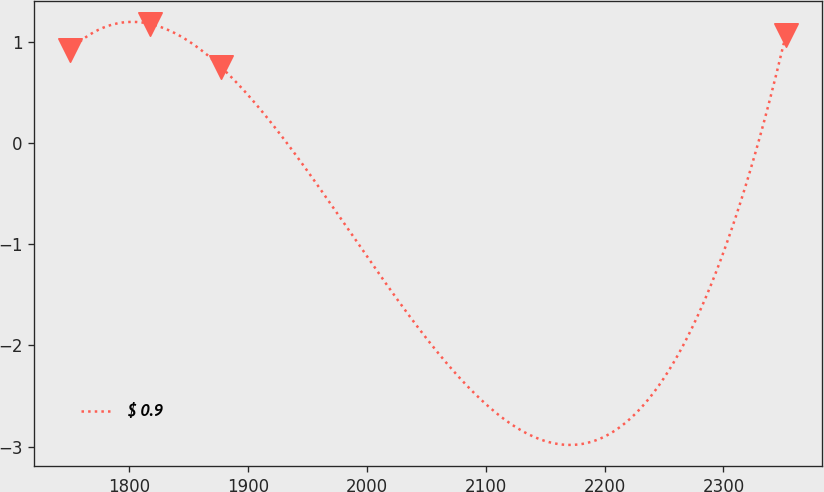<chart> <loc_0><loc_0><loc_500><loc_500><line_chart><ecel><fcel>$ 0.9<nl><fcel>1750.34<fcel>0.92<nl><fcel>1817.56<fcel>1.18<nl><fcel>1877.76<fcel>0.75<nl><fcel>2352.39<fcel>1.07<nl></chart> 